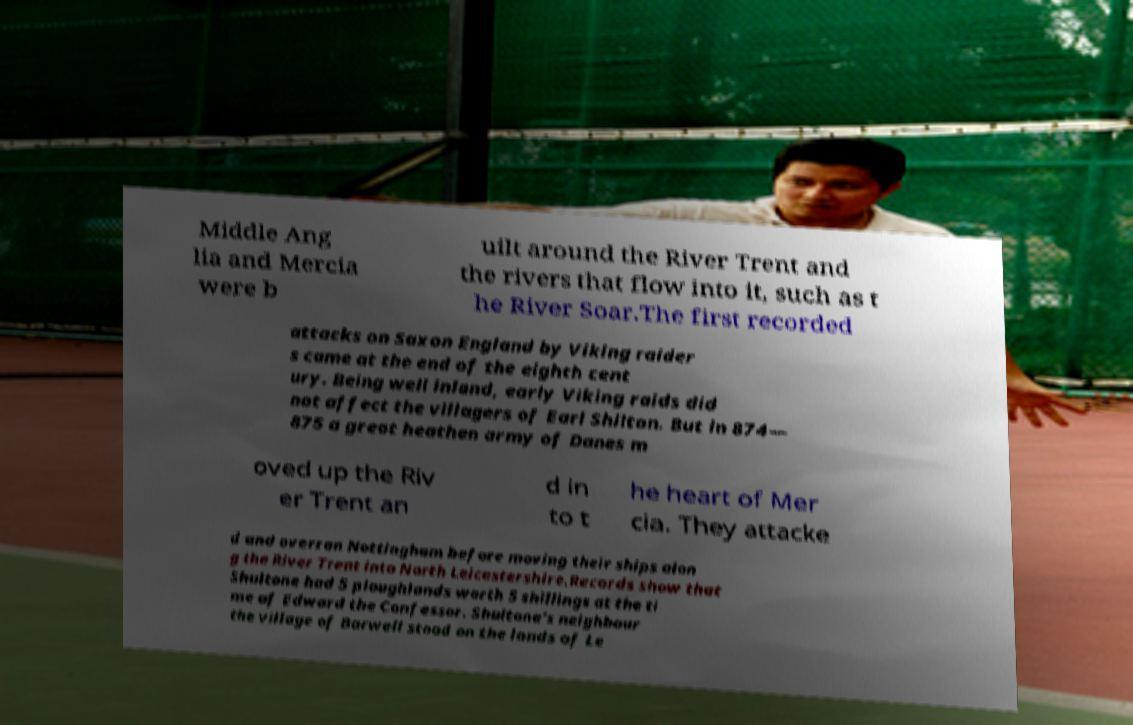What messages or text are displayed in this image? I need them in a readable, typed format. Middle Ang lia and Mercia were b uilt around the River Trent and the rivers that flow into it, such as t he River Soar.The first recorded attacks on Saxon England by Viking raider s came at the end of the eighth cent ury. Being well inland, early Viking raids did not affect the villagers of Earl Shilton. But in 874— 875 a great heathen army of Danes m oved up the Riv er Trent an d in to t he heart of Mer cia. They attacke d and overran Nottingham before moving their ships alon g the River Trent into North Leicestershire.Records show that Shultone had 5 ploughlands worth 5 shillings at the ti me of Edward the Confessor. Shultone’s neighbour the village of Barwell stood on the lands of Le 